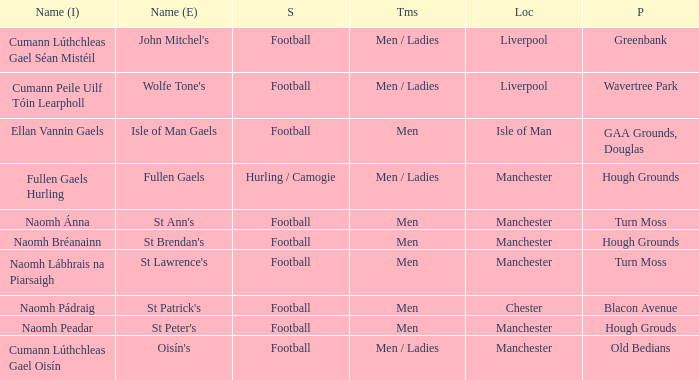Could you parse the entire table as a dict? {'header': ['Name (I)', 'Name (E)', 'S', 'Tms', 'Loc', 'P'], 'rows': [['Cumann Lúthchleas Gael Séan Mistéil', "John Mitchel's", 'Football', 'Men / Ladies', 'Liverpool', 'Greenbank'], ['Cumann Peile Uilf Tóin Learpholl', "Wolfe Tone's", 'Football', 'Men / Ladies', 'Liverpool', 'Wavertree Park'], ['Ellan Vannin Gaels', 'Isle of Man Gaels', 'Football', 'Men', 'Isle of Man', 'GAA Grounds, Douglas'], ['Fullen Gaels Hurling', 'Fullen Gaels', 'Hurling / Camogie', 'Men / Ladies', 'Manchester', 'Hough Grounds'], ['Naomh Ánna', "St Ann's", 'Football', 'Men', 'Manchester', 'Turn Moss'], ['Naomh Bréanainn', "St Brendan's", 'Football', 'Men', 'Manchester', 'Hough Grounds'], ['Naomh Lábhrais na Piarsaigh', "St Lawrence's", 'Football', 'Men', 'Manchester', 'Turn Moss'], ['Naomh Pádraig', "St Patrick's", 'Football', 'Men', 'Chester', 'Blacon Avenue'], ['Naomh Peadar', "St Peter's", 'Football', 'Men', 'Manchester', 'Hough Grouds'], ['Cumann Lúthchleas Gael Oisín', "Oisín's", 'Football', 'Men / Ladies', 'Manchester', 'Old Bedians']]} What Pitch is located at Isle of Man? GAA Grounds, Douglas. 